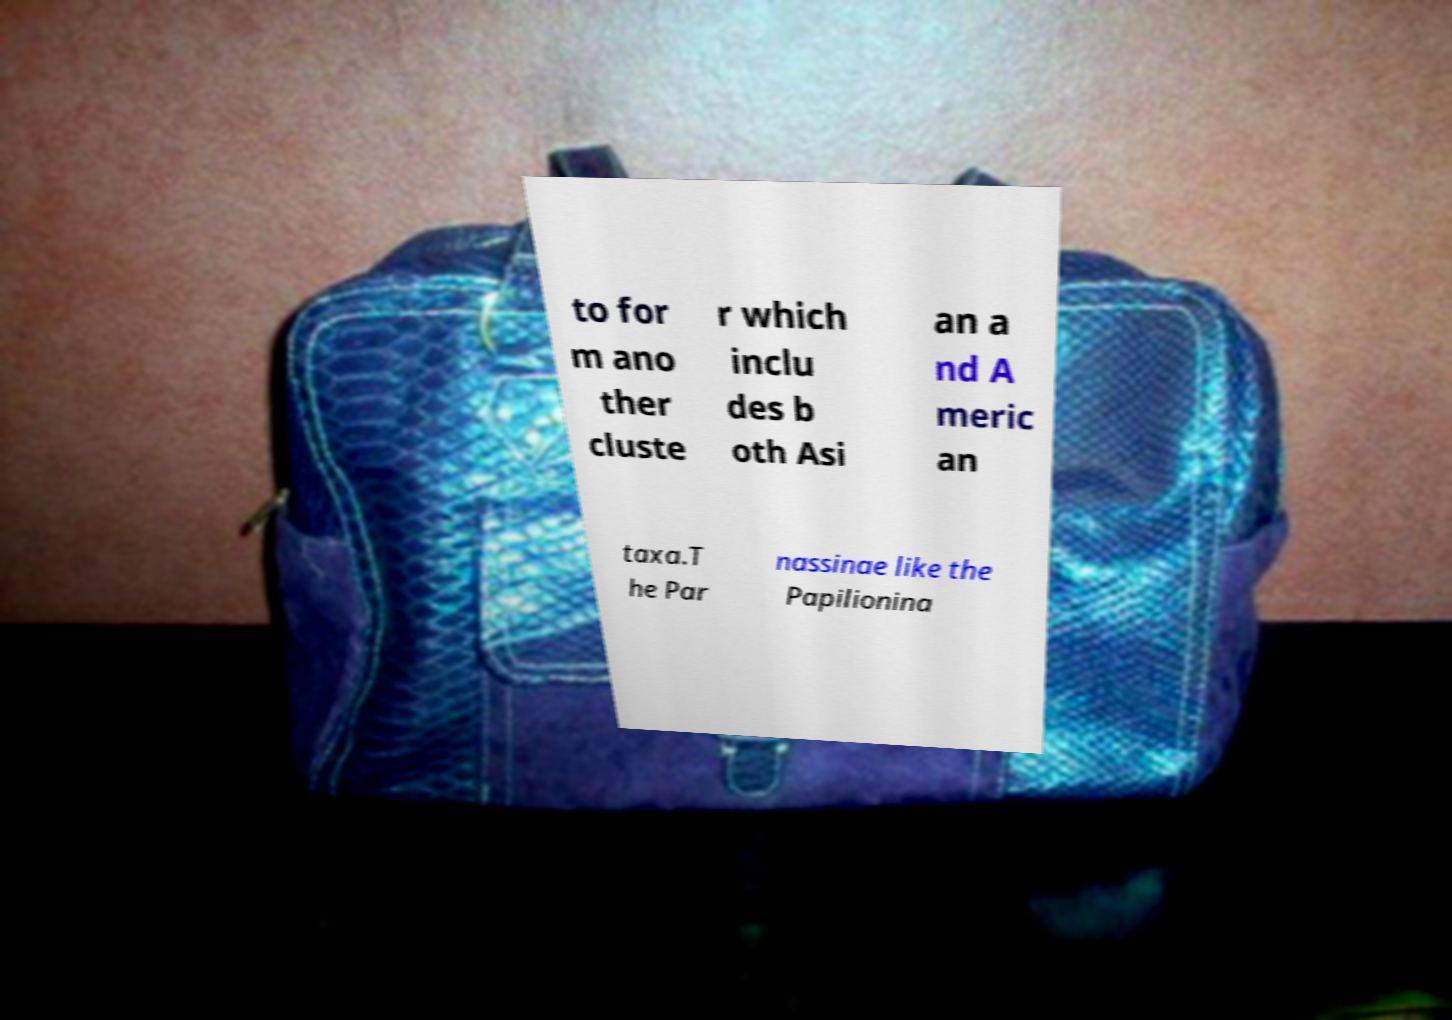Could you assist in decoding the text presented in this image and type it out clearly? to for m ano ther cluste r which inclu des b oth Asi an a nd A meric an taxa.T he Par nassinae like the Papilionina 